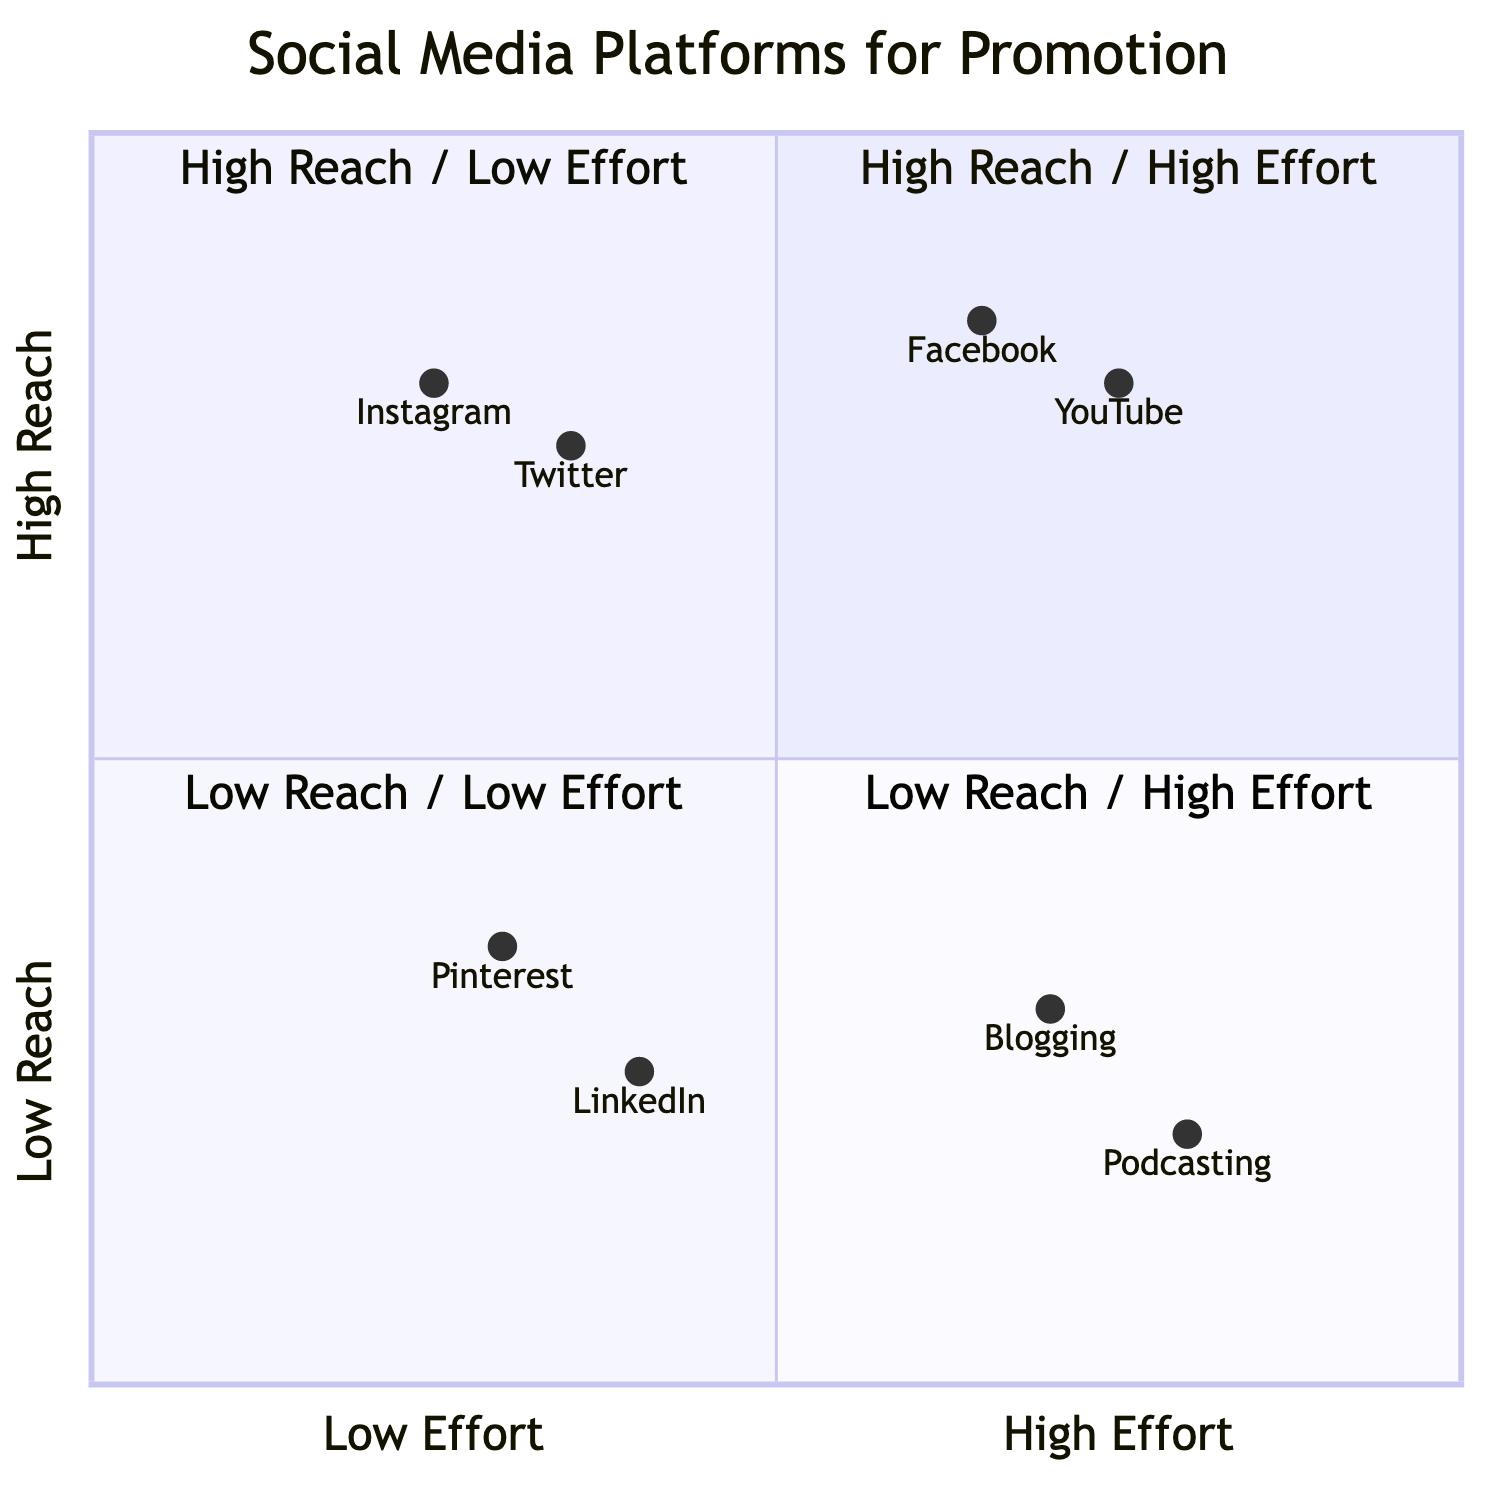What platforms fall under High Reach/High Effort? According to the diagram in the High Reach/High Effort quadrant, the platforms listed are YouTube and Facebook. These platforms require significant effort to promote but have a broad reach.
Answer: YouTube, Facebook Which platform is categorized as Low Reach/Low Effort? In the Low Reach/Low Effort quadrant, the platforms shown are Pinterest and LinkedIn. These are easier to manage but do not reach many people.
Answer: Pinterest, LinkedIn How many platforms are assigned to High Reach/Low Effort? In the High Reach/Low Effort quadrant, there are two platforms: Twitter and Instagram. This indicates that these platforms achieve a wide reach with relatively low effort.
Answer: 2 Which platform in the Low Reach/High Effort category has the highest reach value? In the Low Reach/High Effort quadrant, Blogging and Podcasting are represented. Between the two, Blog has a higher reach value (0.30) compared to Podcasting (0.20).
Answer: Blogging Are there more platforms in High Reach/High Effort or Low Reach/Low Effort? The High Reach/High Effort quadrant has two platforms (YouTube, Facebook) while the Low Reach/Low Effort quadrant also has two platforms (Pinterest, LinkedIn). Therefore, both quadrants contain the same number of platforms.
Answer: Same number Which platform has the lowest reach value overall? Upon analyzing all platforms, Podcasting has the lowest reach value of 0.20, making it the least effective in terms of reach compared to the others in the chart.
Answer: Podcasting What is the relationship between the effort required and reach in the quadrants? The diagram indicates that platforms in the High Reach quadrants (both High and Low Effort) require more effort compared to those in Low Reach (also both Effort categories). High Reach requires more effort, while Low Reach typically requires less effort.
Answer: Higher effort equals higher reach How does Instagram's reach value compare to Twitter's? Instagram has a reach value of 0.80 while Twitter has a reach value of 0.75. Thus, Instagram has a slightly higher reach than Twitter.
Answer: Instagram is higher What are the platforms listed in the Low Reach/High Effort category? The Low Reach/High Effort quadrant lists two platforms: Blogging and Podcasting. These platforms require significant effort yet yield lower reach.
Answer: Blogging, Podcasting 